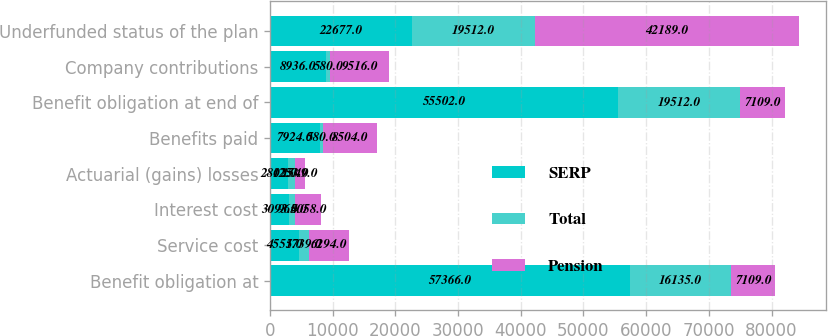<chart> <loc_0><loc_0><loc_500><loc_500><stacked_bar_chart><ecel><fcel>Benefit obligation at<fcel>Service cost<fcel>Interest cost<fcel>Actuarial (gains) losses<fcel>Benefits paid<fcel>Benefit obligation at end of<fcel>Company contributions<fcel>Underfunded status of the plan<nl><fcel>SERP<fcel>57366<fcel>4555<fcel>3093<fcel>2802<fcel>7924<fcel>55502<fcel>8936<fcel>22677<nl><fcel>Total<fcel>16135<fcel>1739<fcel>965<fcel>1253<fcel>580<fcel>19512<fcel>580<fcel>19512<nl><fcel>Pension<fcel>7109<fcel>6294<fcel>4058<fcel>1549<fcel>8504<fcel>7109<fcel>9516<fcel>42189<nl></chart> 